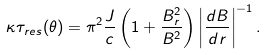Convert formula to latex. <formula><loc_0><loc_0><loc_500><loc_500>\kappa \tau _ { r e s } ( \theta ) = \pi ^ { 2 } \frac { J } { c } \left ( 1 + \frac { B _ { r } ^ { 2 } } { B ^ { 2 } } \right ) \left | \frac { d B } { d r } \right | ^ { - 1 } .</formula> 